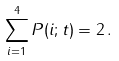<formula> <loc_0><loc_0><loc_500><loc_500>\sum _ { i = 1 } ^ { 4 } P ( i ; t ) = 2 \, .</formula> 